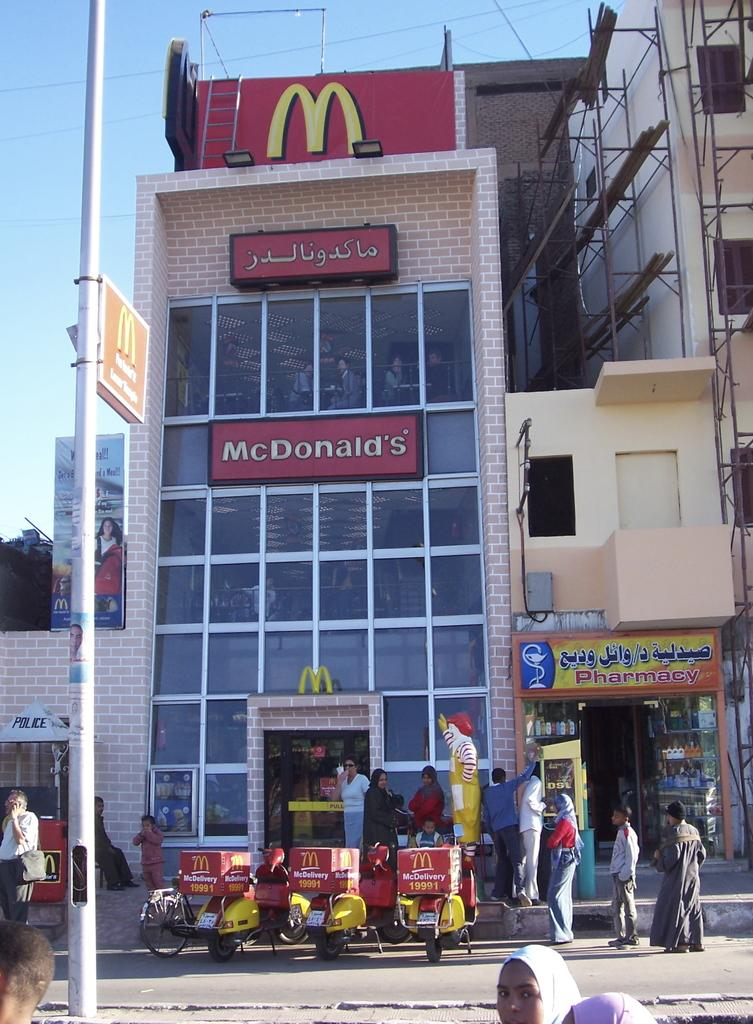Provide a one-sentence caption for the provided image. Three McDonald's delivery scooters sit outside a McDonald's restaurant. 